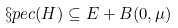Convert formula to latex. <formula><loc_0><loc_0><loc_500><loc_500>\S p e c ( H ) \subseteq E + B ( 0 , \mu )</formula> 